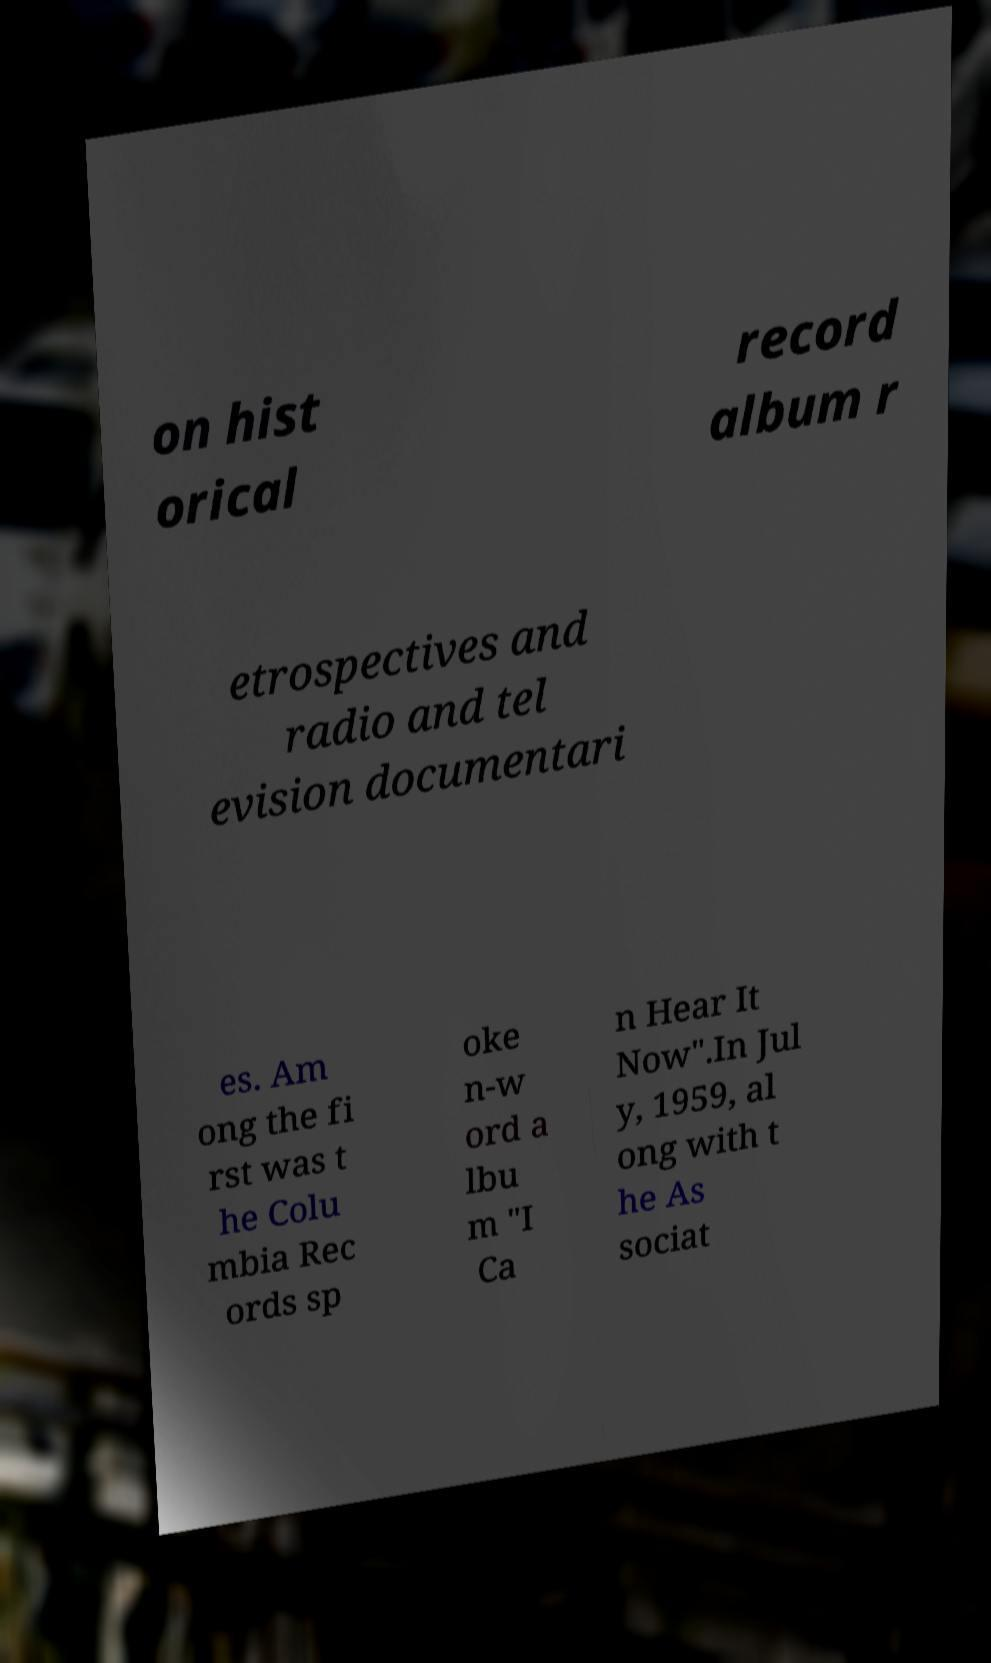Could you extract and type out the text from this image? on hist orical record album r etrospectives and radio and tel evision documentari es. Am ong the fi rst was t he Colu mbia Rec ords sp oke n-w ord a lbu m "I Ca n Hear It Now".In Jul y, 1959, al ong with t he As sociat 